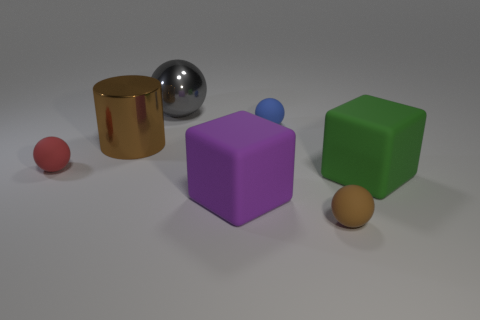What number of red matte objects have the same shape as the gray thing? 1 